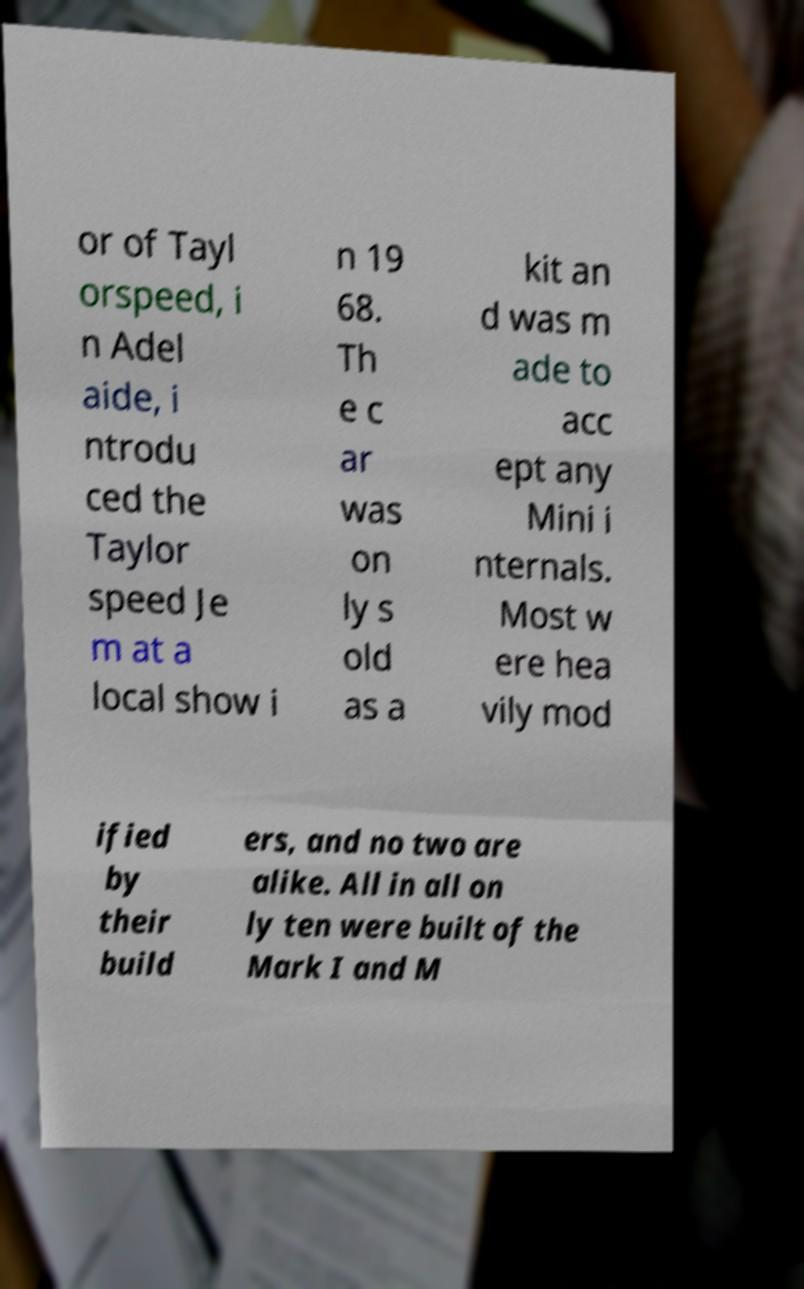What messages or text are displayed in this image? I need them in a readable, typed format. or of Tayl orspeed, i n Adel aide, i ntrodu ced the Taylor speed Je m at a local show i n 19 68. Th e c ar was on ly s old as a kit an d was m ade to acc ept any Mini i nternals. Most w ere hea vily mod ified by their build ers, and no two are alike. All in all on ly ten were built of the Mark I and M 